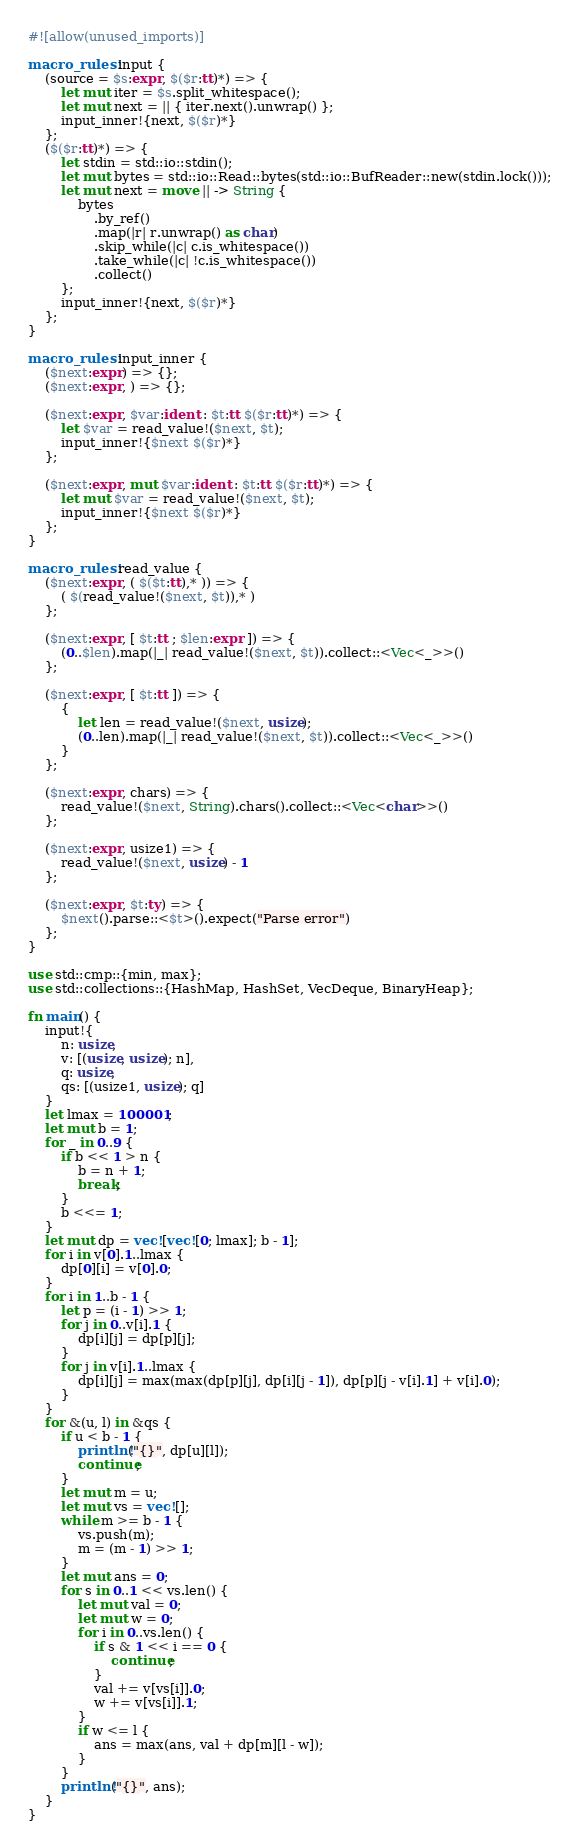<code> <loc_0><loc_0><loc_500><loc_500><_Rust_>#![allow(unused_imports)]

macro_rules! input {
    (source = $s:expr, $($r:tt)*) => {
        let mut iter = $s.split_whitespace();
        let mut next = || { iter.next().unwrap() };
        input_inner!{next, $($r)*}
    };
    ($($r:tt)*) => {
        let stdin = std::io::stdin();
        let mut bytes = std::io::Read::bytes(std::io::BufReader::new(stdin.lock()));
        let mut next = move || -> String {
            bytes
                .by_ref()
                .map(|r| r.unwrap() as char)
                .skip_while(|c| c.is_whitespace())
                .take_while(|c| !c.is_whitespace())
                .collect()
        };
        input_inner!{next, $($r)*}
    };
}

macro_rules! input_inner {
    ($next:expr) => {};
    ($next:expr, ) => {};

    ($next:expr, $var:ident : $t:tt $($r:tt)*) => {
        let $var = read_value!($next, $t);
        input_inner!{$next $($r)*}
    };

    ($next:expr, mut $var:ident : $t:tt $($r:tt)*) => {
        let mut $var = read_value!($next, $t);
        input_inner!{$next $($r)*}
    };
}

macro_rules! read_value {
    ($next:expr, ( $($t:tt),* )) => {
        ( $(read_value!($next, $t)),* )
    };

    ($next:expr, [ $t:tt ; $len:expr ]) => {
        (0..$len).map(|_| read_value!($next, $t)).collect::<Vec<_>>()
    };

    ($next:expr, [ $t:tt ]) => {
        {
            let len = read_value!($next, usize);
            (0..len).map(|_| read_value!($next, $t)).collect::<Vec<_>>()
        }
    };

    ($next:expr, chars) => {
        read_value!($next, String).chars().collect::<Vec<char>>()
    };

    ($next:expr, usize1) => {
        read_value!($next, usize) - 1
    };

    ($next:expr, $t:ty) => {
        $next().parse::<$t>().expect("Parse error")
    };
}

use std::cmp::{min, max};
use std::collections::{HashMap, HashSet, VecDeque, BinaryHeap};

fn main() {
    input!{
        n: usize,
        v: [(usize, usize); n],
        q: usize,
        qs: [(usize1, usize); q]
    }
    let lmax = 100001;
    let mut b = 1;
    for _ in 0..9 {
        if b << 1 > n {
            b = n + 1;
            break;
        }
        b <<= 1;
    }
    let mut dp = vec![vec![0; lmax]; b - 1];
    for i in v[0].1..lmax {
        dp[0][i] = v[0].0;
    }
    for i in 1..b - 1 {
        let p = (i - 1) >> 1;
        for j in 0..v[i].1 {
            dp[i][j] = dp[p][j];
        }
        for j in v[i].1..lmax {
            dp[i][j] = max(max(dp[p][j], dp[i][j - 1]), dp[p][j - v[i].1] + v[i].0);
        }
    }
    for &(u, l) in &qs {
        if u < b - 1 {
            println!("{}", dp[u][l]);
            continue;
        }
        let mut m = u;
        let mut vs = vec![];
        while m >= b - 1 {
            vs.push(m);
            m = (m - 1) >> 1;
        }
        let mut ans = 0;
        for s in 0..1 << vs.len() {
            let mut val = 0;
            let mut w = 0;
            for i in 0..vs.len() {
                if s & 1 << i == 0 {
                    continue;
                }
                val += v[vs[i]].0;
                w += v[vs[i]].1;
            }
            if w <= l {
                ans = max(ans, val + dp[m][l - w]);
            }
        }
        println!("{}", ans);
    }
}
</code> 